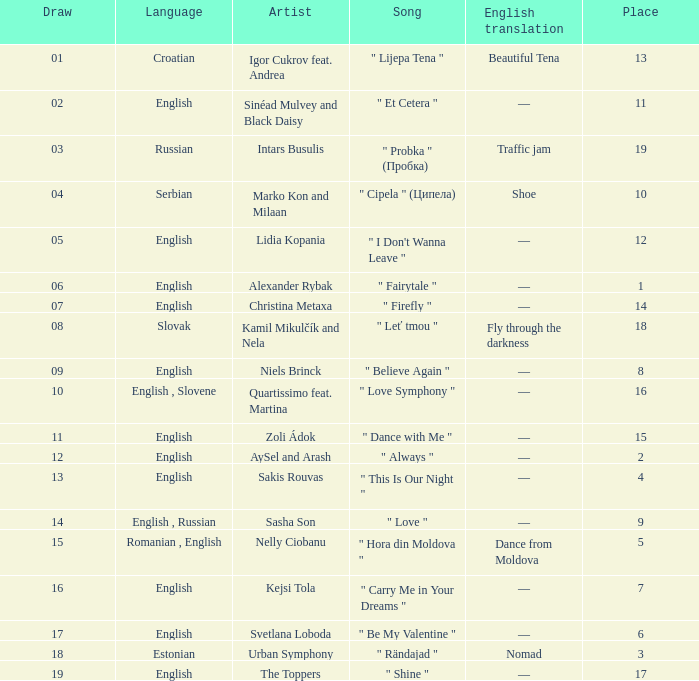What is the median points when the artist is kamil mikulčík and nela, and the location is bigger than 18? None. 